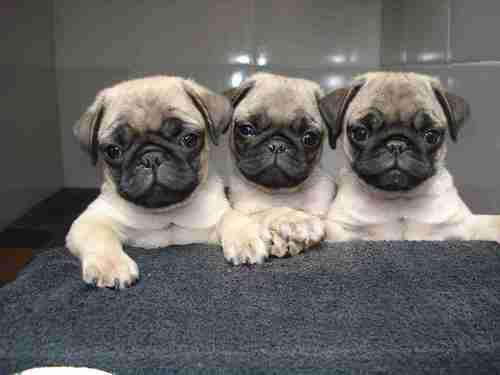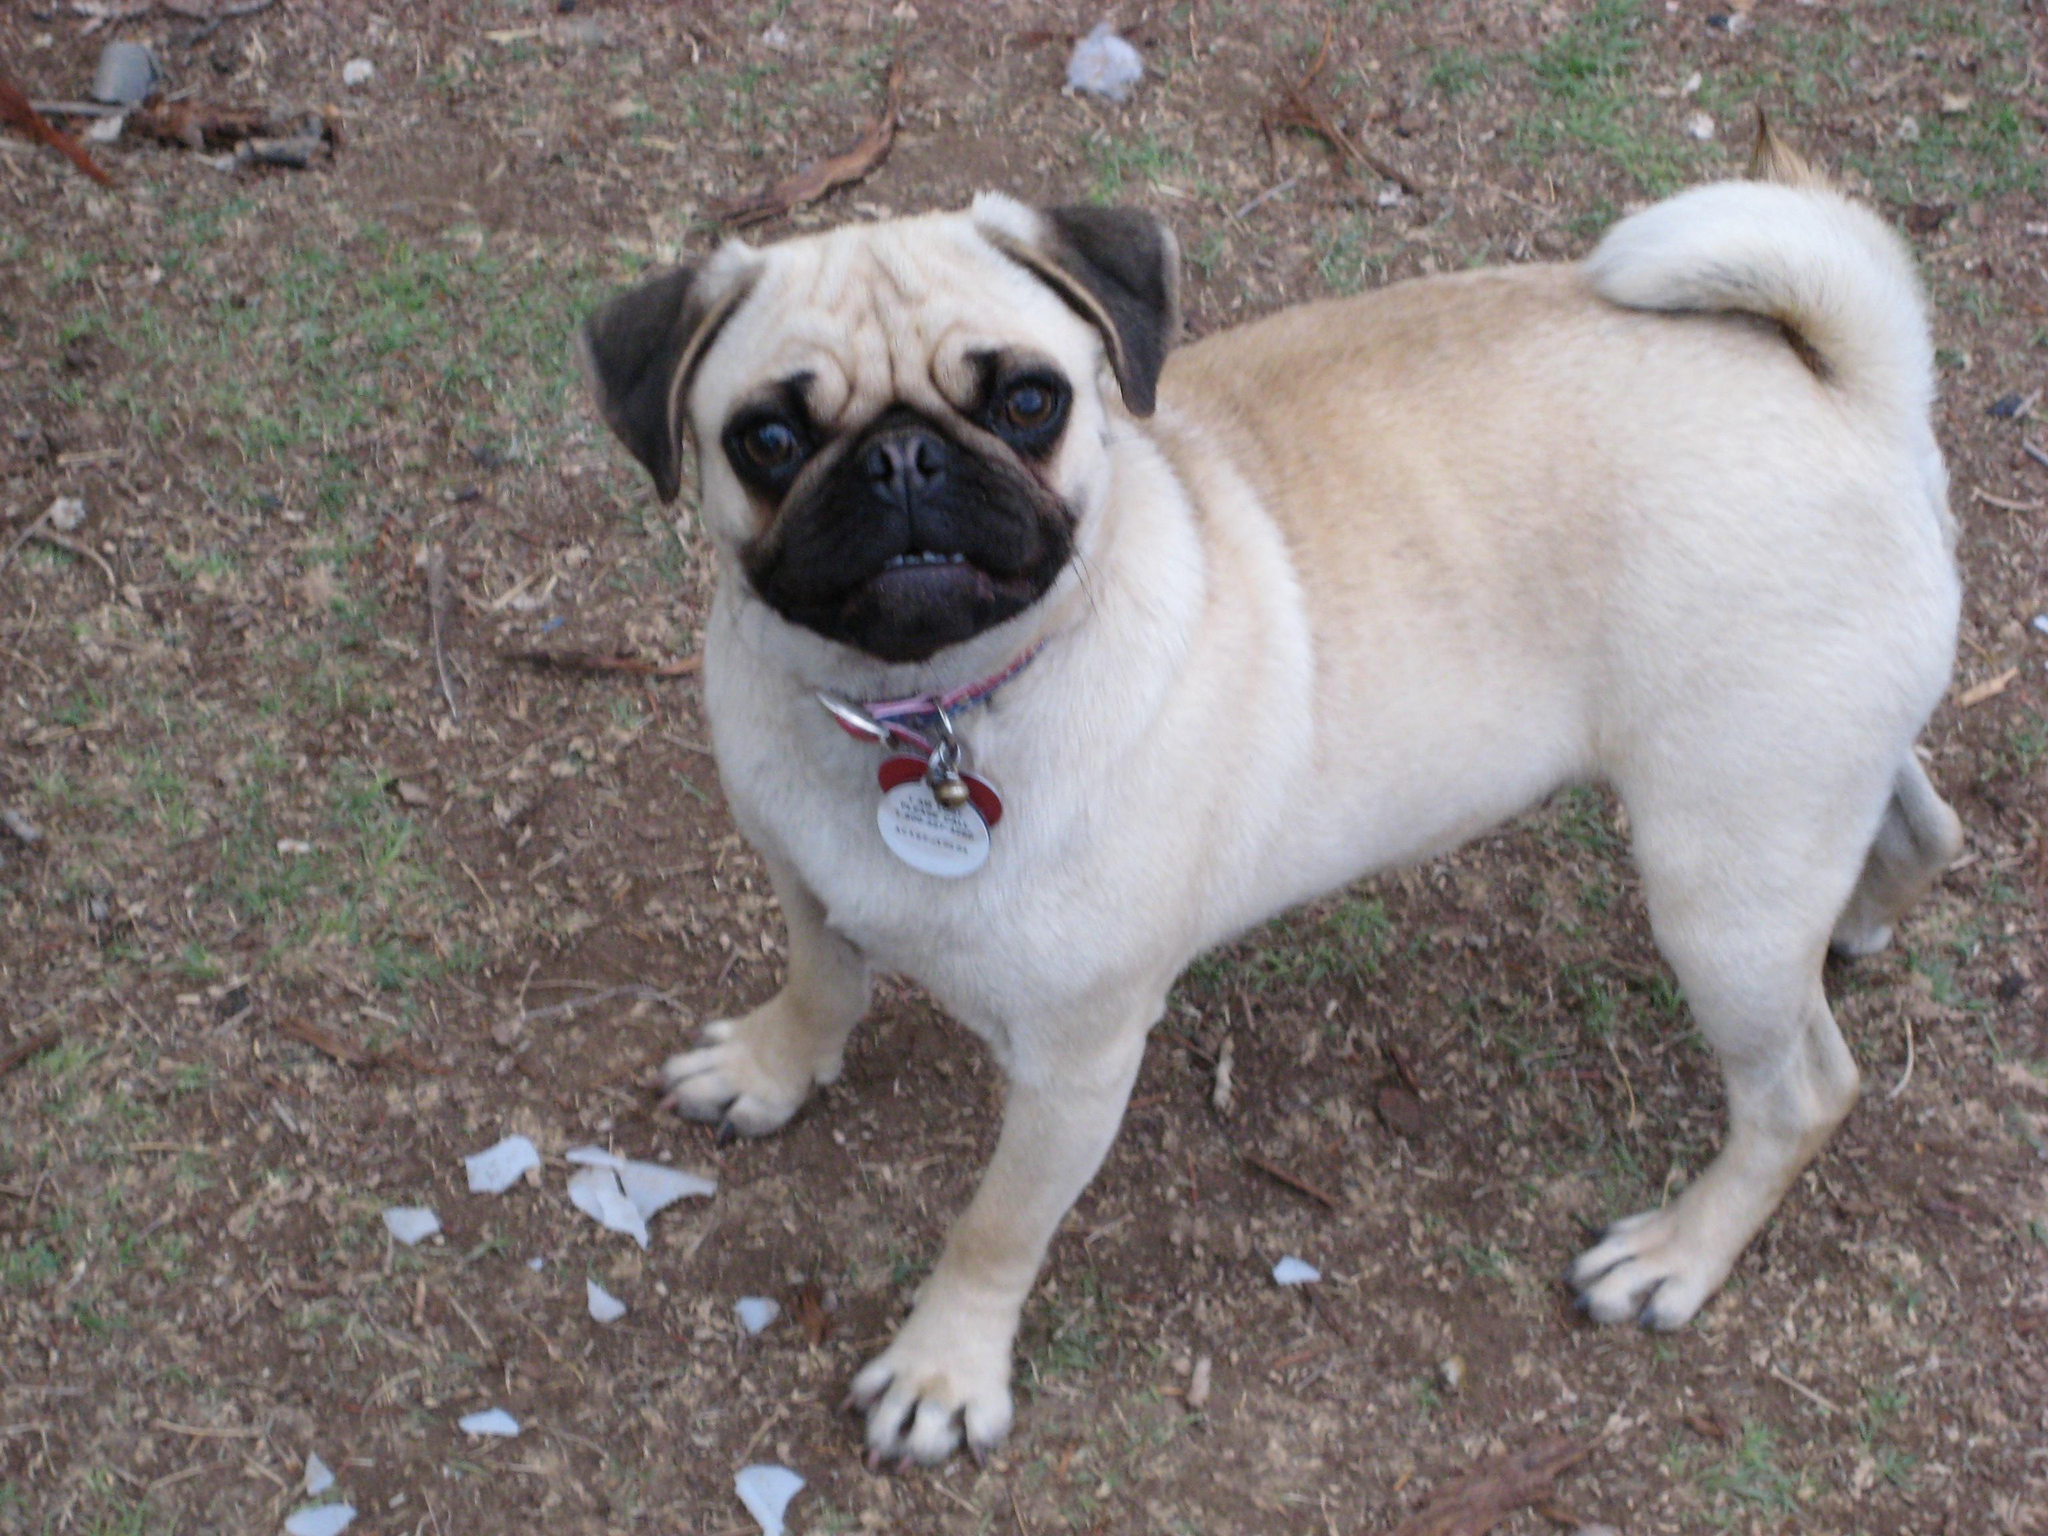The first image is the image on the left, the second image is the image on the right. Considering the images on both sides, is "There are two puppies visible in the image on the right" valid? Answer yes or no. No. The first image is the image on the left, the second image is the image on the right. Given the left and right images, does the statement "There is two pugs in the right image." hold true? Answer yes or no. No. 